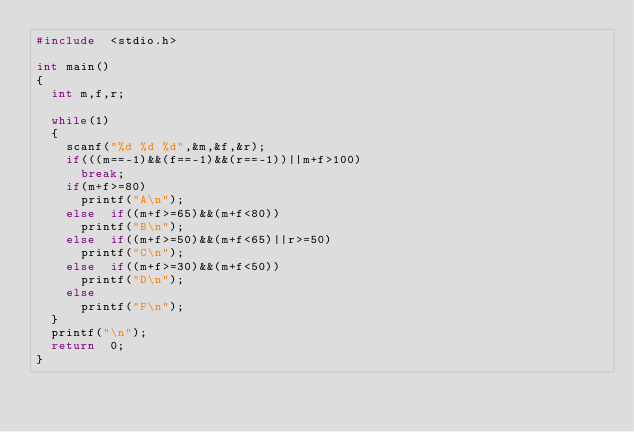<code> <loc_0><loc_0><loc_500><loc_500><_C_>#include  <stdio.h>

int main()
{
	int m,f,r;

	while(1)
	{
		scanf("%d %d %d",&m,&f,&r);
		if(((m==-1)&&(f==-1)&&(r==-1))||m+f>100)
			break;
		if(m+f>=80)
			printf("A\n");
		else  if((m+f>=65)&&(m+f<80))
			printf("B\n");
		else  if((m+f>=50)&&(m+f<65)||r>=50)
			printf("C\n");
		else  if((m+f>=30)&&(m+f<50))
			printf("D\n");
		else  
			printf("F\n");
	}
	printf("\n");
	return  0;
}</code> 